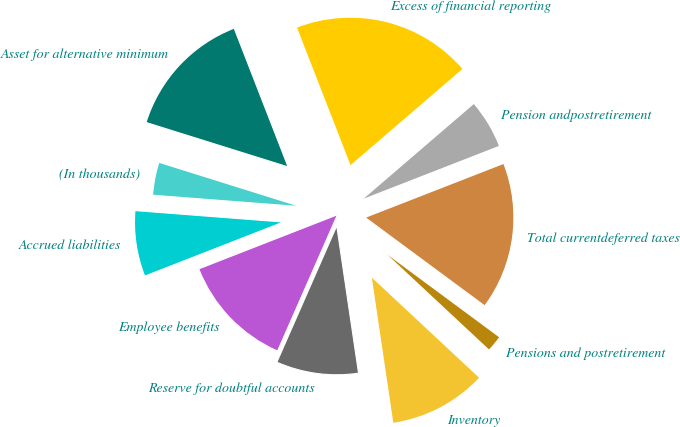Convert chart. <chart><loc_0><loc_0><loc_500><loc_500><pie_chart><fcel>(In thousands)<fcel>Accrued liabilities<fcel>Employee benefits<fcel>Reserve for doubtful accounts<fcel>Inventory<fcel>Pensions and postretirement<fcel>Total currentdeferred taxes<fcel>Pension andpostretirement<fcel>Excess of financial reporting<fcel>Asset for alternative minimum<nl><fcel>3.6%<fcel>7.15%<fcel>12.49%<fcel>8.93%<fcel>10.71%<fcel>1.82%<fcel>16.05%<fcel>5.38%<fcel>19.61%<fcel>14.27%<nl></chart> 